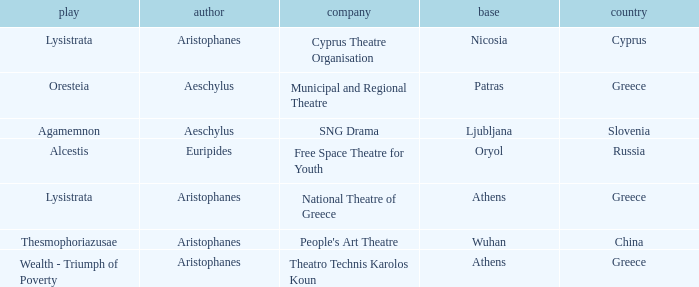What is the play when the company is national theatre of greece? Lysistrata. 